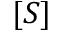<formula> <loc_0><loc_0><loc_500><loc_500>[ S ]</formula> 